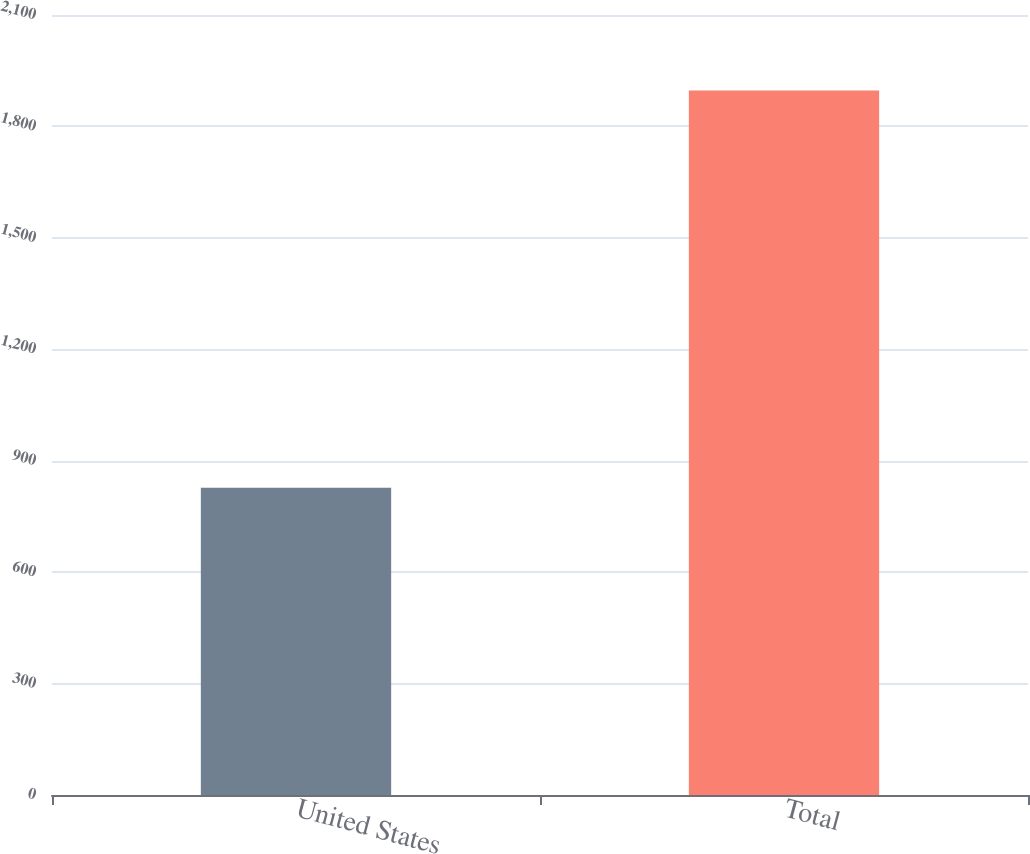Convert chart. <chart><loc_0><loc_0><loc_500><loc_500><bar_chart><fcel>United States<fcel>Total<nl><fcel>827<fcel>1897<nl></chart> 